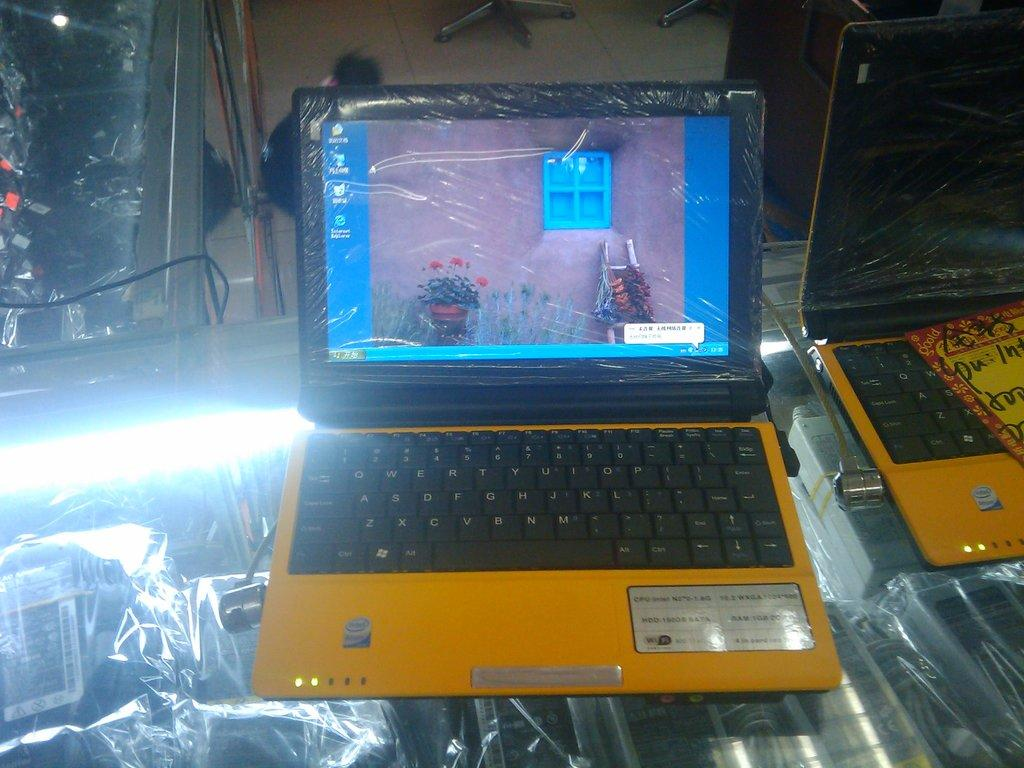Provide a one-sentence caption for the provided image. Two yellow laptops with intel processors, one is on but still in shrink wrap. 